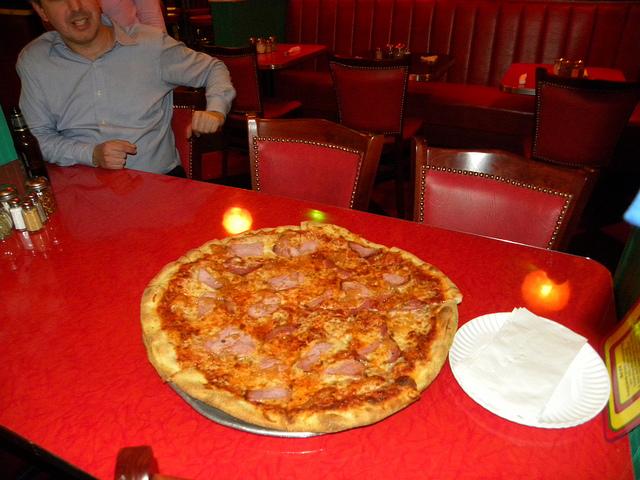How many candles on the table?
Quick response, please. 2. What kind of place is this?
Write a very short answer. Restaurant. What is on the white paper plate?
Give a very brief answer. Napkin. How many pizzas are there?
Answer briefly. 1. 